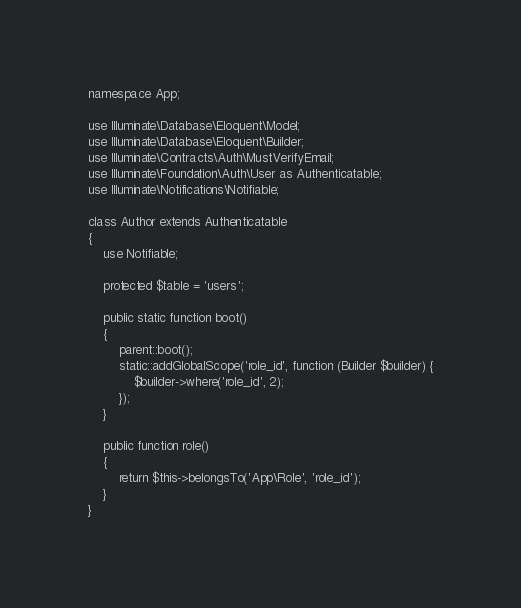Convert code to text. <code><loc_0><loc_0><loc_500><loc_500><_PHP_>
namespace App;

use Illuminate\Database\Eloquent\Model;
use Illuminate\Database\Eloquent\Builder;
use Illuminate\Contracts\Auth\MustVerifyEmail;
use Illuminate\Foundation\Auth\User as Authenticatable;
use Illuminate\Notifications\Notifiable;

class Author extends Authenticatable
{
    use Notifiable;
    
    protected $table = 'users';

    public static function boot()
    {
        parent::boot();
        static::addGlobalScope('role_id', function (Builder $builder) {
            $builder->where('role_id', 2);
        });
    }

    public function role()
    {
        return $this->belongsTo('App\Role', 'role_id');
    }
}
</code> 